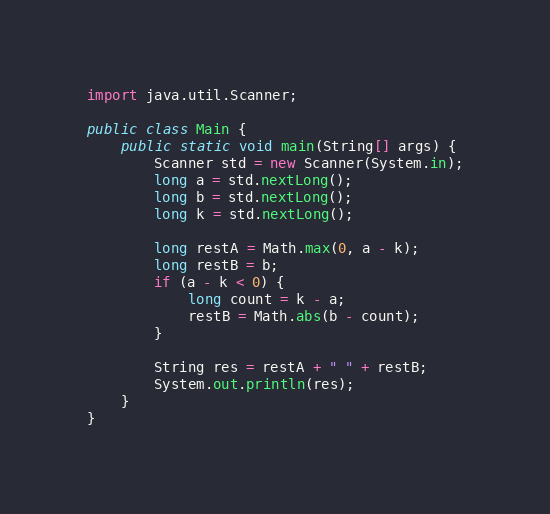<code> <loc_0><loc_0><loc_500><loc_500><_Java_>import java.util.Scanner;

public class Main {
    public static void main(String[] args) {
        Scanner std = new Scanner(System.in);
        long a = std.nextLong();
        long b = std.nextLong();
        long k = std.nextLong();

        long restA = Math.max(0, a - k);
        long restB = b;
        if (a - k < 0) {
            long count = k - a;
            restB = Math.abs(b - count);
        }

        String res = restA + " " + restB;
        System.out.println(res);
    }
}
</code> 